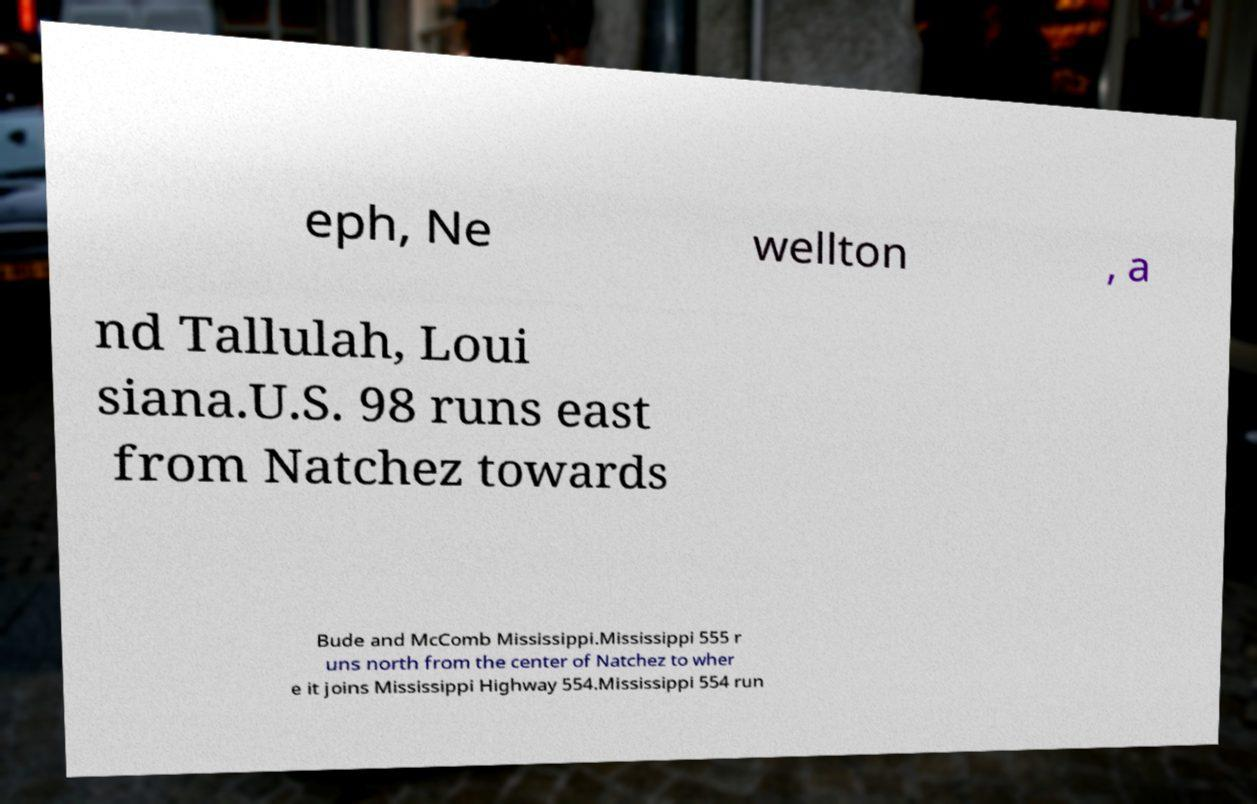Could you extract and type out the text from this image? eph, Ne wellton , a nd Tallulah, Loui siana.U.S. 98 runs east from Natchez towards Bude and McComb Mississippi.Mississippi 555 r uns north from the center of Natchez to wher e it joins Mississippi Highway 554.Mississippi 554 run 